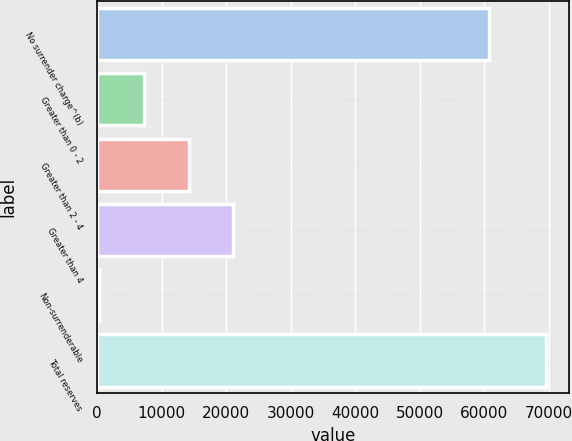Convert chart. <chart><loc_0><loc_0><loc_500><loc_500><bar_chart><fcel>No surrender charge^(b)<fcel>Greater than 0 - 2<fcel>Greater than 2 - 4<fcel>Greater than 4<fcel>Non-surrenderable<fcel>Total reserves<nl><fcel>60743<fcel>7286.2<fcel>14212.4<fcel>21138.6<fcel>360<fcel>69622<nl></chart> 